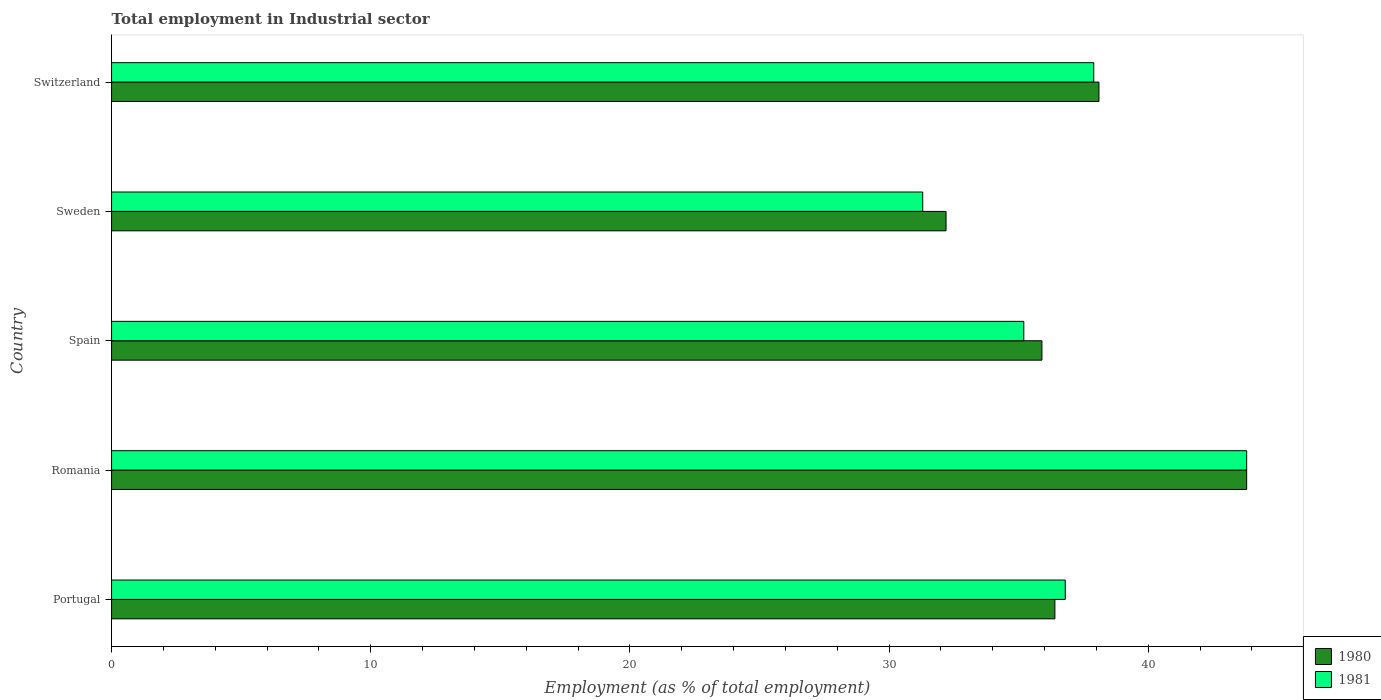How many different coloured bars are there?
Offer a very short reply. 2. Are the number of bars per tick equal to the number of legend labels?
Keep it short and to the point. Yes. Are the number of bars on each tick of the Y-axis equal?
Make the answer very short. Yes. How many bars are there on the 3rd tick from the top?
Your answer should be compact. 2. What is the label of the 5th group of bars from the top?
Give a very brief answer. Portugal. What is the employment in industrial sector in 1980 in Portugal?
Your answer should be compact. 36.4. Across all countries, what is the maximum employment in industrial sector in 1980?
Give a very brief answer. 43.8. Across all countries, what is the minimum employment in industrial sector in 1980?
Provide a succinct answer. 32.2. In which country was the employment in industrial sector in 1980 maximum?
Make the answer very short. Romania. In which country was the employment in industrial sector in 1981 minimum?
Provide a succinct answer. Sweden. What is the total employment in industrial sector in 1980 in the graph?
Ensure brevity in your answer.  186.4. What is the difference between the employment in industrial sector in 1980 in Spain and that in Sweden?
Keep it short and to the point. 3.7. What is the difference between the employment in industrial sector in 1981 in Spain and the employment in industrial sector in 1980 in Portugal?
Make the answer very short. -1.2. What is the average employment in industrial sector in 1981 per country?
Provide a succinct answer. 37. What is the difference between the employment in industrial sector in 1980 and employment in industrial sector in 1981 in Spain?
Offer a terse response. 0.7. In how many countries, is the employment in industrial sector in 1980 greater than 2 %?
Provide a short and direct response. 5. What is the ratio of the employment in industrial sector in 1980 in Portugal to that in Spain?
Offer a very short reply. 1.01. Is the difference between the employment in industrial sector in 1980 in Romania and Spain greater than the difference between the employment in industrial sector in 1981 in Romania and Spain?
Your answer should be compact. No. What is the difference between the highest and the second highest employment in industrial sector in 1981?
Give a very brief answer. 5.9. What is the difference between the highest and the lowest employment in industrial sector in 1980?
Provide a short and direct response. 11.6. Is the sum of the employment in industrial sector in 1980 in Spain and Switzerland greater than the maximum employment in industrial sector in 1981 across all countries?
Offer a terse response. Yes. What does the 1st bar from the bottom in Switzerland represents?
Give a very brief answer. 1980. What is the difference between two consecutive major ticks on the X-axis?
Provide a short and direct response. 10. Are the values on the major ticks of X-axis written in scientific E-notation?
Ensure brevity in your answer.  No. Does the graph contain any zero values?
Give a very brief answer. No. Does the graph contain grids?
Your answer should be compact. No. How are the legend labels stacked?
Give a very brief answer. Vertical. What is the title of the graph?
Give a very brief answer. Total employment in Industrial sector. What is the label or title of the X-axis?
Provide a short and direct response. Employment (as % of total employment). What is the Employment (as % of total employment) of 1980 in Portugal?
Ensure brevity in your answer.  36.4. What is the Employment (as % of total employment) of 1981 in Portugal?
Offer a very short reply. 36.8. What is the Employment (as % of total employment) in 1980 in Romania?
Offer a terse response. 43.8. What is the Employment (as % of total employment) of 1981 in Romania?
Keep it short and to the point. 43.8. What is the Employment (as % of total employment) of 1980 in Spain?
Ensure brevity in your answer.  35.9. What is the Employment (as % of total employment) in 1981 in Spain?
Make the answer very short. 35.2. What is the Employment (as % of total employment) in 1980 in Sweden?
Make the answer very short. 32.2. What is the Employment (as % of total employment) in 1981 in Sweden?
Give a very brief answer. 31.3. What is the Employment (as % of total employment) in 1980 in Switzerland?
Keep it short and to the point. 38.1. What is the Employment (as % of total employment) of 1981 in Switzerland?
Give a very brief answer. 37.9. Across all countries, what is the maximum Employment (as % of total employment) in 1980?
Provide a short and direct response. 43.8. Across all countries, what is the maximum Employment (as % of total employment) of 1981?
Ensure brevity in your answer.  43.8. Across all countries, what is the minimum Employment (as % of total employment) in 1980?
Keep it short and to the point. 32.2. Across all countries, what is the minimum Employment (as % of total employment) of 1981?
Offer a very short reply. 31.3. What is the total Employment (as % of total employment) of 1980 in the graph?
Your answer should be compact. 186.4. What is the total Employment (as % of total employment) of 1981 in the graph?
Ensure brevity in your answer.  185. What is the difference between the Employment (as % of total employment) of 1980 in Portugal and that in Spain?
Ensure brevity in your answer.  0.5. What is the difference between the Employment (as % of total employment) in 1981 in Portugal and that in Sweden?
Offer a terse response. 5.5. What is the difference between the Employment (as % of total employment) of 1980 in Portugal and that in Switzerland?
Provide a succinct answer. -1.7. What is the difference between the Employment (as % of total employment) of 1981 in Portugal and that in Switzerland?
Provide a short and direct response. -1.1. What is the difference between the Employment (as % of total employment) in 1981 in Romania and that in Sweden?
Give a very brief answer. 12.5. What is the difference between the Employment (as % of total employment) of 1981 in Romania and that in Switzerland?
Provide a short and direct response. 5.9. What is the difference between the Employment (as % of total employment) of 1980 in Spain and that in Switzerland?
Provide a succinct answer. -2.2. What is the difference between the Employment (as % of total employment) in 1981 in Spain and that in Switzerland?
Provide a succinct answer. -2.7. What is the difference between the Employment (as % of total employment) of 1981 in Sweden and that in Switzerland?
Offer a terse response. -6.6. What is the difference between the Employment (as % of total employment) in 1980 in Portugal and the Employment (as % of total employment) in 1981 in Romania?
Keep it short and to the point. -7.4. What is the difference between the Employment (as % of total employment) of 1980 in Portugal and the Employment (as % of total employment) of 1981 in Spain?
Ensure brevity in your answer.  1.2. What is the difference between the Employment (as % of total employment) of 1980 in Portugal and the Employment (as % of total employment) of 1981 in Sweden?
Ensure brevity in your answer.  5.1. What is the difference between the Employment (as % of total employment) in 1980 in Portugal and the Employment (as % of total employment) in 1981 in Switzerland?
Keep it short and to the point. -1.5. What is the difference between the Employment (as % of total employment) of 1980 in Romania and the Employment (as % of total employment) of 1981 in Spain?
Provide a short and direct response. 8.6. What is the difference between the Employment (as % of total employment) of 1980 in Romania and the Employment (as % of total employment) of 1981 in Switzerland?
Provide a succinct answer. 5.9. What is the difference between the Employment (as % of total employment) of 1980 in Spain and the Employment (as % of total employment) of 1981 in Switzerland?
Your answer should be very brief. -2. What is the difference between the Employment (as % of total employment) of 1980 in Sweden and the Employment (as % of total employment) of 1981 in Switzerland?
Offer a terse response. -5.7. What is the average Employment (as % of total employment) in 1980 per country?
Your answer should be compact. 37.28. What is the difference between the Employment (as % of total employment) of 1980 and Employment (as % of total employment) of 1981 in Portugal?
Give a very brief answer. -0.4. What is the difference between the Employment (as % of total employment) in 1980 and Employment (as % of total employment) in 1981 in Spain?
Make the answer very short. 0.7. What is the difference between the Employment (as % of total employment) of 1980 and Employment (as % of total employment) of 1981 in Switzerland?
Your response must be concise. 0.2. What is the ratio of the Employment (as % of total employment) of 1980 in Portugal to that in Romania?
Give a very brief answer. 0.83. What is the ratio of the Employment (as % of total employment) of 1981 in Portugal to that in Romania?
Give a very brief answer. 0.84. What is the ratio of the Employment (as % of total employment) of 1980 in Portugal to that in Spain?
Provide a succinct answer. 1.01. What is the ratio of the Employment (as % of total employment) of 1981 in Portugal to that in Spain?
Make the answer very short. 1.05. What is the ratio of the Employment (as % of total employment) in 1980 in Portugal to that in Sweden?
Provide a succinct answer. 1.13. What is the ratio of the Employment (as % of total employment) of 1981 in Portugal to that in Sweden?
Your answer should be compact. 1.18. What is the ratio of the Employment (as % of total employment) of 1980 in Portugal to that in Switzerland?
Your answer should be compact. 0.96. What is the ratio of the Employment (as % of total employment) of 1980 in Romania to that in Spain?
Offer a very short reply. 1.22. What is the ratio of the Employment (as % of total employment) of 1981 in Romania to that in Spain?
Your answer should be very brief. 1.24. What is the ratio of the Employment (as % of total employment) of 1980 in Romania to that in Sweden?
Your answer should be very brief. 1.36. What is the ratio of the Employment (as % of total employment) of 1981 in Romania to that in Sweden?
Your answer should be compact. 1.4. What is the ratio of the Employment (as % of total employment) in 1980 in Romania to that in Switzerland?
Offer a terse response. 1.15. What is the ratio of the Employment (as % of total employment) of 1981 in Romania to that in Switzerland?
Give a very brief answer. 1.16. What is the ratio of the Employment (as % of total employment) in 1980 in Spain to that in Sweden?
Provide a succinct answer. 1.11. What is the ratio of the Employment (as % of total employment) of 1981 in Spain to that in Sweden?
Give a very brief answer. 1.12. What is the ratio of the Employment (as % of total employment) of 1980 in Spain to that in Switzerland?
Provide a short and direct response. 0.94. What is the ratio of the Employment (as % of total employment) in 1981 in Spain to that in Switzerland?
Your answer should be very brief. 0.93. What is the ratio of the Employment (as % of total employment) of 1980 in Sweden to that in Switzerland?
Provide a short and direct response. 0.85. What is the ratio of the Employment (as % of total employment) in 1981 in Sweden to that in Switzerland?
Your answer should be compact. 0.83. What is the difference between the highest and the second highest Employment (as % of total employment) of 1980?
Ensure brevity in your answer.  5.7. What is the difference between the highest and the second highest Employment (as % of total employment) in 1981?
Your response must be concise. 5.9. What is the difference between the highest and the lowest Employment (as % of total employment) of 1980?
Make the answer very short. 11.6. 